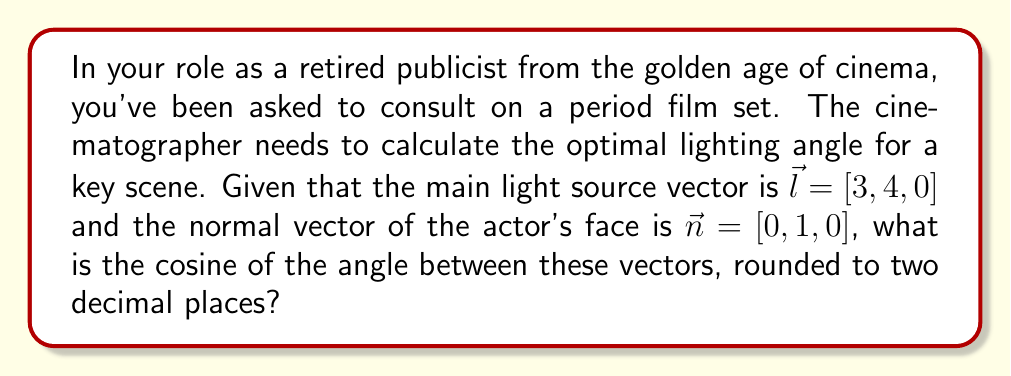Provide a solution to this math problem. To solve this problem, we'll use vector projection and the dot product formula. Here's the step-by-step solution:

1) The cosine of the angle between two vectors can be calculated using the dot product formula:

   $$\cos \theta = \frac{\vec{l} \cdot \vec{n}}{|\vec{l}| |\vec{n}|}$$

2) First, let's calculate the dot product $\vec{l} \cdot \vec{n}$:
   
   $\vec{l} \cdot \vec{n} = 3(0) + 4(1) + 0(0) = 4$

3) Next, we need to calculate the magnitudes of both vectors:

   $|\vec{l}| = \sqrt{3^2 + 4^2 + 0^2} = \sqrt{25} = 5$
   
   $|\vec{n}| = \sqrt{0^2 + 1^2 + 0^2} = 1$

4) Now we can plug these values into our formula:

   $$\cos \theta = \frac{4}{5 \cdot 1} = \frac{4}{5} = 0.8$$

5) Rounding to two decimal places:

   $\cos \theta \approx 0.80$

This cosine value represents how directly the light is hitting the actor's face. A value of 1 would mean the light is perfectly perpendicular to the face, while 0 would mean the light is parallel to the face (no direct illumination).
Answer: 0.80 